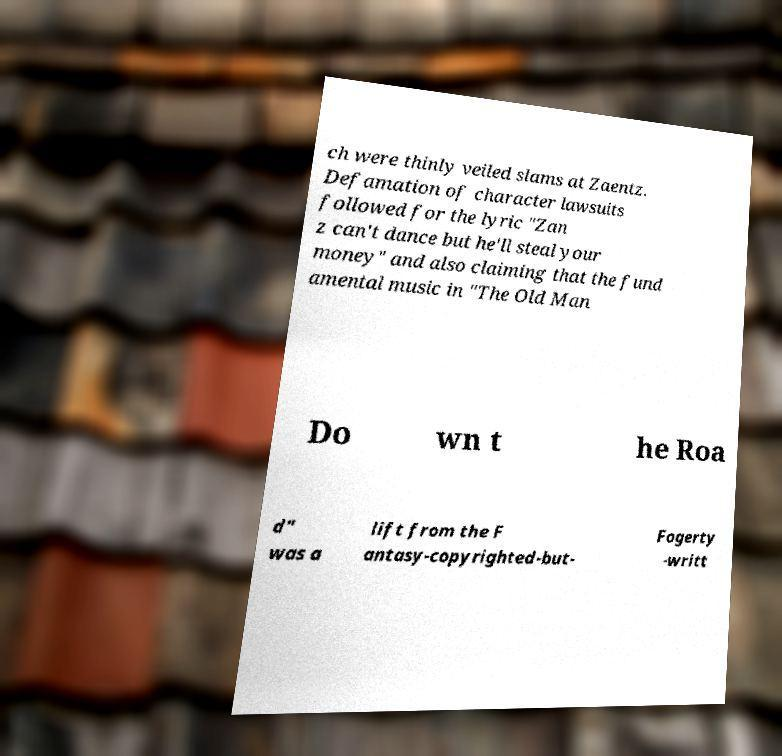Could you assist in decoding the text presented in this image and type it out clearly? ch were thinly veiled slams at Zaentz. Defamation of character lawsuits followed for the lyric "Zan z can't dance but he'll steal your money" and also claiming that the fund amental music in "The Old Man Do wn t he Roa d" was a lift from the F antasy-copyrighted-but- Fogerty -writt 